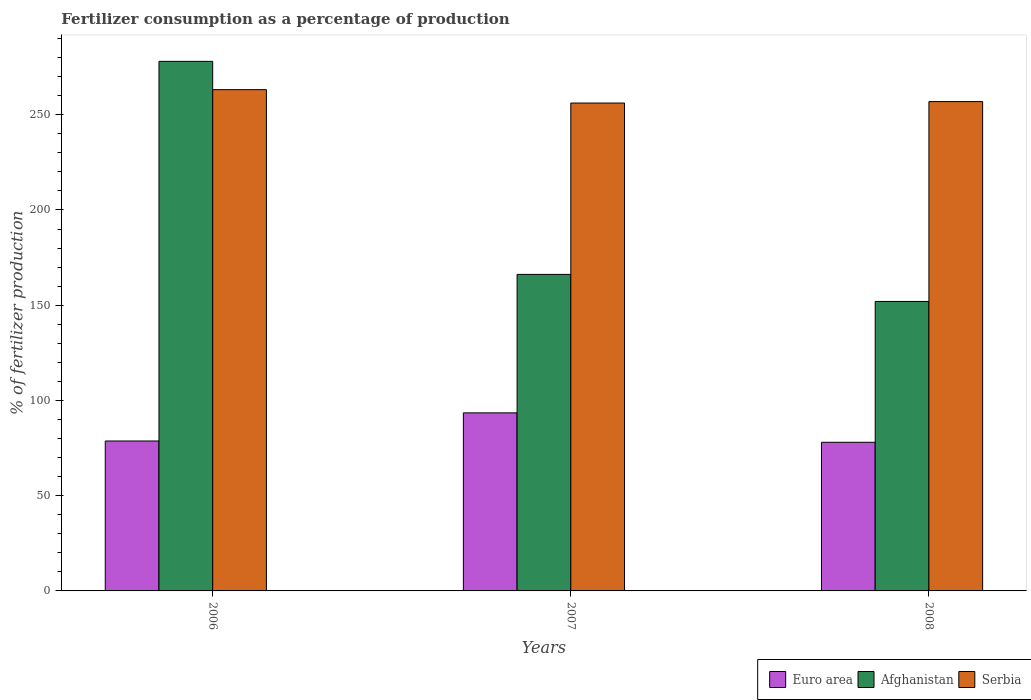Are the number of bars on each tick of the X-axis equal?
Provide a short and direct response. Yes. How many bars are there on the 1st tick from the left?
Offer a terse response. 3. How many bars are there on the 2nd tick from the right?
Offer a very short reply. 3. What is the label of the 3rd group of bars from the left?
Your answer should be compact. 2008. What is the percentage of fertilizers consumed in Afghanistan in 2006?
Your response must be concise. 278.02. Across all years, what is the maximum percentage of fertilizers consumed in Euro area?
Ensure brevity in your answer.  93.48. Across all years, what is the minimum percentage of fertilizers consumed in Afghanistan?
Offer a terse response. 151.98. In which year was the percentage of fertilizers consumed in Euro area minimum?
Provide a succinct answer. 2008. What is the total percentage of fertilizers consumed in Serbia in the graph?
Ensure brevity in your answer.  776.2. What is the difference between the percentage of fertilizers consumed in Serbia in 2006 and that in 2007?
Make the answer very short. 7.03. What is the difference between the percentage of fertilizers consumed in Afghanistan in 2008 and the percentage of fertilizers consumed in Serbia in 2007?
Give a very brief answer. -104.16. What is the average percentage of fertilizers consumed in Euro area per year?
Keep it short and to the point. 83.41. In the year 2007, what is the difference between the percentage of fertilizers consumed in Afghanistan and percentage of fertilizers consumed in Euro area?
Make the answer very short. 72.69. What is the ratio of the percentage of fertilizers consumed in Afghanistan in 2006 to that in 2008?
Provide a succinct answer. 1.83. Is the percentage of fertilizers consumed in Afghanistan in 2006 less than that in 2007?
Your answer should be compact. No. What is the difference between the highest and the second highest percentage of fertilizers consumed in Serbia?
Your answer should be very brief. 6.27. What is the difference between the highest and the lowest percentage of fertilizers consumed in Serbia?
Give a very brief answer. 7.03. In how many years, is the percentage of fertilizers consumed in Afghanistan greater than the average percentage of fertilizers consumed in Afghanistan taken over all years?
Keep it short and to the point. 1. What does the 1st bar from the left in 2007 represents?
Give a very brief answer. Euro area. What does the 1st bar from the right in 2008 represents?
Offer a terse response. Serbia. What is the difference between two consecutive major ticks on the Y-axis?
Your response must be concise. 50. Does the graph contain any zero values?
Your response must be concise. No. Does the graph contain grids?
Provide a succinct answer. No. Where does the legend appear in the graph?
Keep it short and to the point. Bottom right. How many legend labels are there?
Ensure brevity in your answer.  3. How are the legend labels stacked?
Keep it short and to the point. Horizontal. What is the title of the graph?
Your answer should be compact. Fertilizer consumption as a percentage of production. What is the label or title of the X-axis?
Offer a very short reply. Years. What is the label or title of the Y-axis?
Your answer should be compact. % of fertilizer production. What is the % of fertilizer production of Euro area in 2006?
Your answer should be very brief. 78.71. What is the % of fertilizer production of Afghanistan in 2006?
Your response must be concise. 278.02. What is the % of fertilizer production in Serbia in 2006?
Provide a short and direct response. 263.16. What is the % of fertilizer production of Euro area in 2007?
Offer a very short reply. 93.48. What is the % of fertilizer production of Afghanistan in 2007?
Keep it short and to the point. 166.18. What is the % of fertilizer production of Serbia in 2007?
Provide a succinct answer. 256.14. What is the % of fertilizer production of Euro area in 2008?
Your answer should be compact. 78.04. What is the % of fertilizer production in Afghanistan in 2008?
Your response must be concise. 151.98. What is the % of fertilizer production in Serbia in 2008?
Provide a succinct answer. 256.9. Across all years, what is the maximum % of fertilizer production of Euro area?
Offer a very short reply. 93.48. Across all years, what is the maximum % of fertilizer production of Afghanistan?
Your response must be concise. 278.02. Across all years, what is the maximum % of fertilizer production of Serbia?
Your answer should be very brief. 263.16. Across all years, what is the minimum % of fertilizer production of Euro area?
Your response must be concise. 78.04. Across all years, what is the minimum % of fertilizer production in Afghanistan?
Your response must be concise. 151.98. Across all years, what is the minimum % of fertilizer production in Serbia?
Your answer should be compact. 256.14. What is the total % of fertilizer production of Euro area in the graph?
Your answer should be very brief. 250.23. What is the total % of fertilizer production in Afghanistan in the graph?
Your answer should be very brief. 596.18. What is the total % of fertilizer production in Serbia in the graph?
Provide a succinct answer. 776.2. What is the difference between the % of fertilizer production of Euro area in 2006 and that in 2007?
Give a very brief answer. -14.77. What is the difference between the % of fertilizer production in Afghanistan in 2006 and that in 2007?
Provide a short and direct response. 111.85. What is the difference between the % of fertilizer production in Serbia in 2006 and that in 2007?
Offer a terse response. 7.03. What is the difference between the % of fertilizer production in Euro area in 2006 and that in 2008?
Your answer should be compact. 0.68. What is the difference between the % of fertilizer production in Afghanistan in 2006 and that in 2008?
Your response must be concise. 126.04. What is the difference between the % of fertilizer production in Serbia in 2006 and that in 2008?
Your answer should be very brief. 6.27. What is the difference between the % of fertilizer production of Euro area in 2007 and that in 2008?
Provide a succinct answer. 15.45. What is the difference between the % of fertilizer production of Afghanistan in 2007 and that in 2008?
Offer a terse response. 14.2. What is the difference between the % of fertilizer production of Serbia in 2007 and that in 2008?
Your answer should be compact. -0.76. What is the difference between the % of fertilizer production in Euro area in 2006 and the % of fertilizer production in Afghanistan in 2007?
Provide a short and direct response. -87.46. What is the difference between the % of fertilizer production in Euro area in 2006 and the % of fertilizer production in Serbia in 2007?
Provide a short and direct response. -177.43. What is the difference between the % of fertilizer production in Afghanistan in 2006 and the % of fertilizer production in Serbia in 2007?
Your answer should be compact. 21.88. What is the difference between the % of fertilizer production of Euro area in 2006 and the % of fertilizer production of Afghanistan in 2008?
Your response must be concise. -73.27. What is the difference between the % of fertilizer production in Euro area in 2006 and the % of fertilizer production in Serbia in 2008?
Your answer should be very brief. -178.18. What is the difference between the % of fertilizer production in Afghanistan in 2006 and the % of fertilizer production in Serbia in 2008?
Your answer should be very brief. 21.13. What is the difference between the % of fertilizer production in Euro area in 2007 and the % of fertilizer production in Afghanistan in 2008?
Offer a terse response. -58.5. What is the difference between the % of fertilizer production in Euro area in 2007 and the % of fertilizer production in Serbia in 2008?
Your response must be concise. -163.41. What is the difference between the % of fertilizer production in Afghanistan in 2007 and the % of fertilizer production in Serbia in 2008?
Keep it short and to the point. -90.72. What is the average % of fertilizer production of Euro area per year?
Ensure brevity in your answer.  83.41. What is the average % of fertilizer production in Afghanistan per year?
Offer a terse response. 198.73. What is the average % of fertilizer production in Serbia per year?
Give a very brief answer. 258.73. In the year 2006, what is the difference between the % of fertilizer production in Euro area and % of fertilizer production in Afghanistan?
Provide a succinct answer. -199.31. In the year 2006, what is the difference between the % of fertilizer production in Euro area and % of fertilizer production in Serbia?
Keep it short and to the point. -184.45. In the year 2006, what is the difference between the % of fertilizer production in Afghanistan and % of fertilizer production in Serbia?
Provide a succinct answer. 14.86. In the year 2007, what is the difference between the % of fertilizer production in Euro area and % of fertilizer production in Afghanistan?
Your answer should be very brief. -72.69. In the year 2007, what is the difference between the % of fertilizer production of Euro area and % of fertilizer production of Serbia?
Provide a succinct answer. -162.66. In the year 2007, what is the difference between the % of fertilizer production of Afghanistan and % of fertilizer production of Serbia?
Ensure brevity in your answer.  -89.96. In the year 2008, what is the difference between the % of fertilizer production of Euro area and % of fertilizer production of Afghanistan?
Your answer should be very brief. -73.94. In the year 2008, what is the difference between the % of fertilizer production in Euro area and % of fertilizer production in Serbia?
Your response must be concise. -178.86. In the year 2008, what is the difference between the % of fertilizer production of Afghanistan and % of fertilizer production of Serbia?
Your answer should be compact. -104.92. What is the ratio of the % of fertilizer production in Euro area in 2006 to that in 2007?
Provide a short and direct response. 0.84. What is the ratio of the % of fertilizer production of Afghanistan in 2006 to that in 2007?
Make the answer very short. 1.67. What is the ratio of the % of fertilizer production in Serbia in 2006 to that in 2007?
Offer a terse response. 1.03. What is the ratio of the % of fertilizer production in Euro area in 2006 to that in 2008?
Provide a short and direct response. 1.01. What is the ratio of the % of fertilizer production of Afghanistan in 2006 to that in 2008?
Provide a succinct answer. 1.83. What is the ratio of the % of fertilizer production in Serbia in 2006 to that in 2008?
Make the answer very short. 1.02. What is the ratio of the % of fertilizer production in Euro area in 2007 to that in 2008?
Ensure brevity in your answer.  1.2. What is the ratio of the % of fertilizer production in Afghanistan in 2007 to that in 2008?
Provide a short and direct response. 1.09. What is the ratio of the % of fertilizer production in Serbia in 2007 to that in 2008?
Offer a terse response. 1. What is the difference between the highest and the second highest % of fertilizer production of Euro area?
Your answer should be very brief. 14.77. What is the difference between the highest and the second highest % of fertilizer production in Afghanistan?
Keep it short and to the point. 111.85. What is the difference between the highest and the second highest % of fertilizer production in Serbia?
Ensure brevity in your answer.  6.27. What is the difference between the highest and the lowest % of fertilizer production in Euro area?
Your answer should be very brief. 15.45. What is the difference between the highest and the lowest % of fertilizer production in Afghanistan?
Offer a very short reply. 126.04. What is the difference between the highest and the lowest % of fertilizer production in Serbia?
Your answer should be compact. 7.03. 